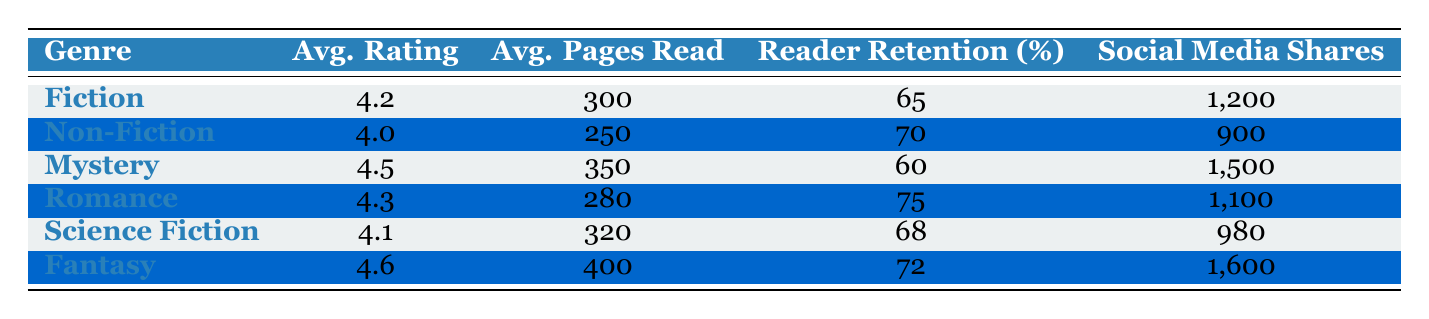What's the average rating for the Fantasy genre? The table shows that the average rating for the Fantasy genre is 4.6. This value is listed directly under the Avg. Rating column for Fantasy.
Answer: 4.6 What is the average number of pages read for the Mystery genre? Looking at the table, the Mystery genre has an average number of pages read listed as 350 in the Avg. Pages Read column.
Answer: 350 Which genre has the highest reader retention rate? By comparing the values in the Reader Retention (%) column, the Romance genre has the highest retention rate at 75%.
Answer: Romance How many total social media shares were made for Fiction and Non-Fiction combined? To find the total, we add the Social Media Shares for Fiction (1200) and Non-Fiction (900). The calculation is 1200 + 900 = 2100.
Answer: 2100 Is the average rating for Non-Fiction greater than that for Science Fiction? The average rating for Non-Fiction is 4.0, while the average rating for Science Fiction is 4.1. Since 4.0 is not greater than 4.1, the answer is no.
Answer: No What is the difference in average pages read between Fantasy and Mystery genres? The average pages read for Fantasy is 400 and for Mystery is 350. The difference is calculated as 400 - 350 = 50.
Answer: 50 Which genres have an average rating higher than 4.4? From the table, the genres with an average rating higher than 4.4 are Mystery (4.5) and Fantasy (4.6). Both these values are directly listed in the Avg. Rating column.
Answer: Mystery, Fantasy If the total number of social media shares for all genres is calculated, what would it be? By summing the Social Media Shares across all genres: 1200 (Fiction) + 900 (Non-Fiction) + 1500 (Mystery) + 1100 (Romance) + 980 (Science Fiction) + 1600 (Fantasy), the total is 1200 + 900 + 1500 + 1100 + 980 + 1600 = 6180.
Answer: 6180 Does the Fiction genre have a higher average rating than the Science Fiction genre? Fiction has an average rating of 4.2, while Science Fiction has an average rating of 4.1. Since 4.2 is greater than 4.1, the answer is yes.
Answer: Yes 